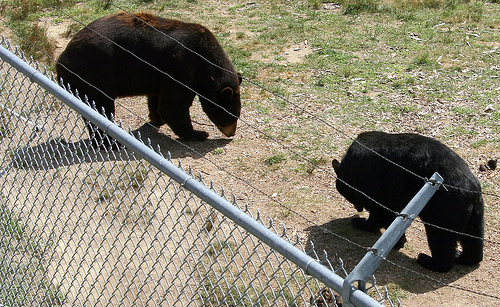What are the bears doing in this image? The two bears seem to be engaging in separate activities. One appears to be walking with its head lowered, possibly sniffing the ground or searching for food, while the second bear is in a different section behind the fence, potentially exploring its own area. 